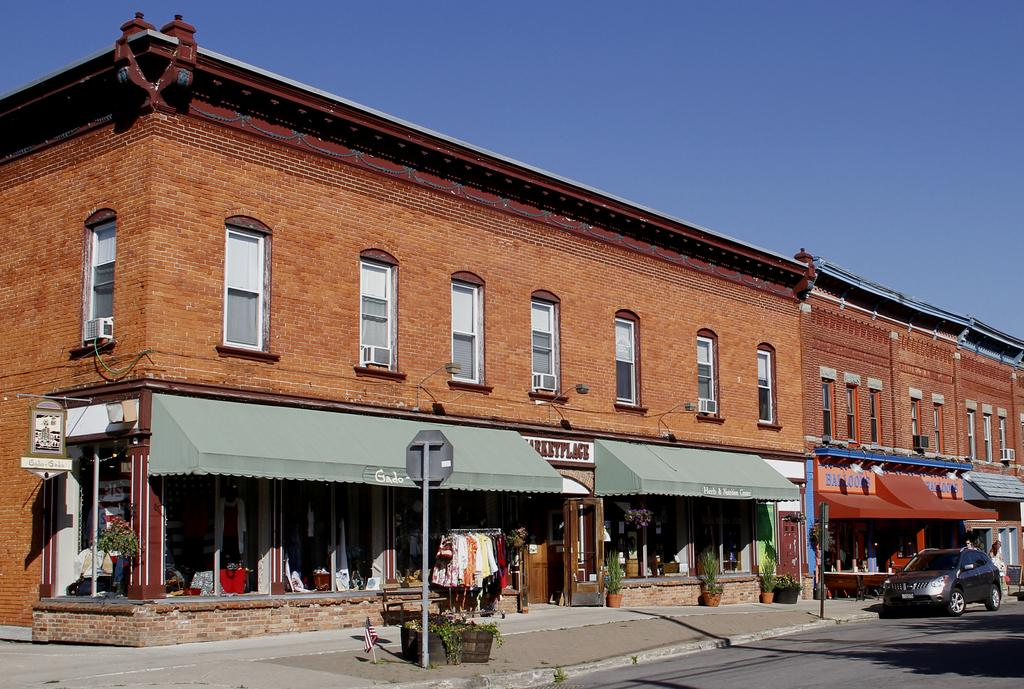What type of structures can be seen in the image? There are buildings in the image. What feature is common to many of the buildings in the image? There are windows in the image. What object is present near the buildings? There is a sign pole in the image. What type of natural elements are visible in the image? There are plants in the image. What type of vehicle can be seen in the image? There is a black color car in the image. What type of personal items are visible in the image? There are clothes visible in the image. What part of the natural environment is visible in the image? The sky is visible in the image. What type of oatmeal is being served in the image? There is no oatmeal present in the image. What country is depicted in the image? The image does not depict a specific country; it shows buildings, plants, and other elements that could be found in various locations. 